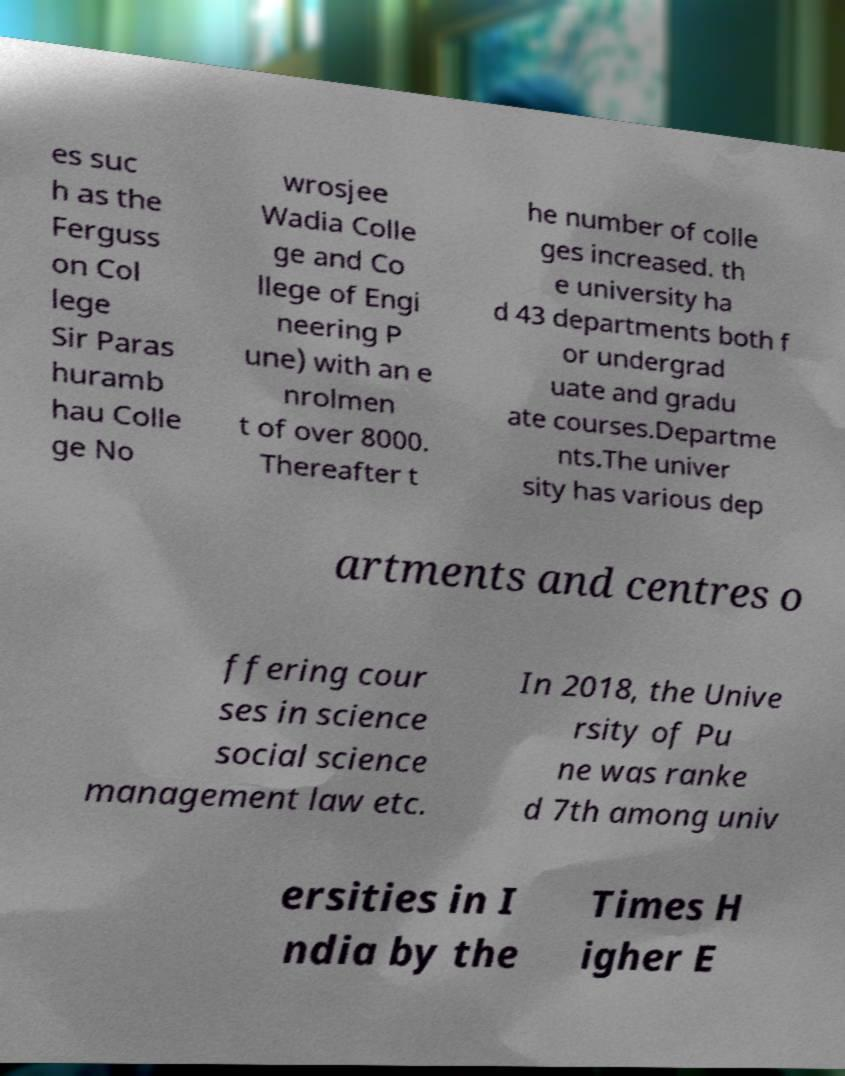For documentation purposes, I need the text within this image transcribed. Could you provide that? es suc h as the Ferguss on Col lege Sir Paras huramb hau Colle ge No wrosjee Wadia Colle ge and Co llege of Engi neering P une) with an e nrolmen t of over 8000. Thereafter t he number of colle ges increased. th e university ha d 43 departments both f or undergrad uate and gradu ate courses.Departme nts.The univer sity has various dep artments and centres o ffering cour ses in science social science management law etc. In 2018, the Unive rsity of Pu ne was ranke d 7th among univ ersities in I ndia by the Times H igher E 